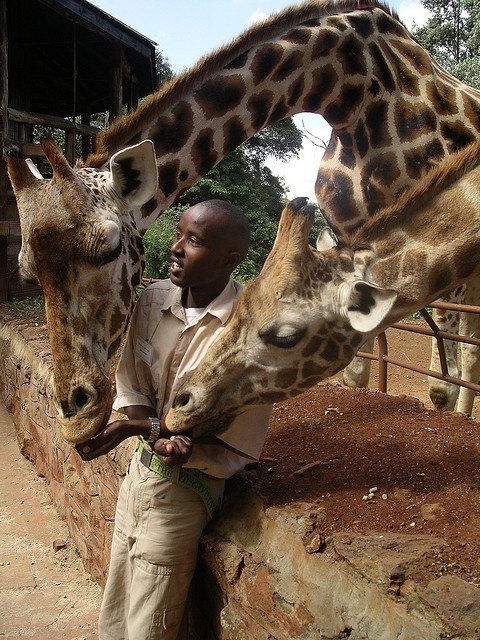Describe the objects in this image and their specific colors. I can see giraffe in black, maroon, and gray tones, giraffe in black, maroon, and tan tones, and people in black, maroon, and gray tones in this image. 